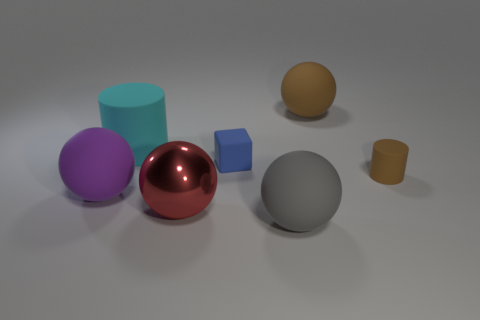Subtract 1 balls. How many balls are left? 3 Add 1 large green rubber blocks. How many objects exist? 8 Subtract all blocks. How many objects are left? 6 Subtract all tiny blue objects. Subtract all matte objects. How many objects are left? 0 Add 5 blue matte cubes. How many blue matte cubes are left? 6 Add 3 small brown balls. How many small brown balls exist? 3 Subtract 1 blue blocks. How many objects are left? 6 